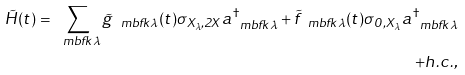<formula> <loc_0><loc_0><loc_500><loc_500>\tilde { H } ( t ) = \sum _ { \ m b f { k } \lambda } \tilde { g } _ { \ m b f { k } \lambda } ( t ) \sigma _ { X _ { \lambda } , 2 X } a _ { \ m b f { k } \lambda } ^ { \dagger } + \tilde { f } _ { \ m b f { k } \lambda } ( t ) \sigma _ { 0 , X _ { \lambda } } a _ { \ m b f { k } \lambda } ^ { \dagger } \\ + h . c . ,</formula> 